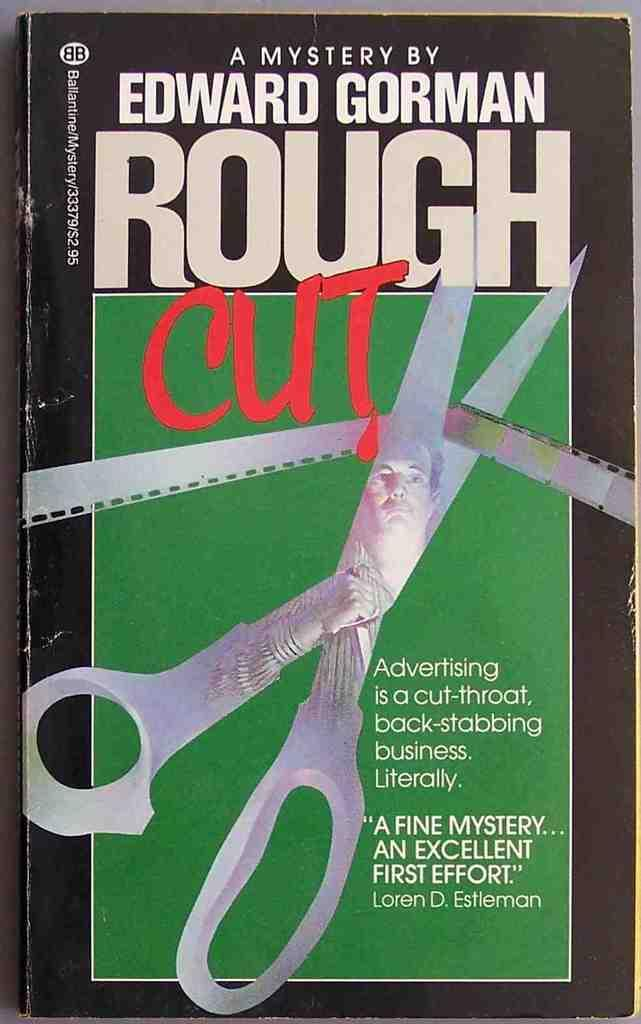Provide a one-sentence caption for the provided image. A mystery book by Edward Gorman shows a pair of scissors cutting through a film reel on the cover. 